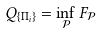Convert formula to latex. <formula><loc_0><loc_0><loc_500><loc_500>Q _ { \{ \Pi _ { i } \} } = \inf _ { \mathcal { P } } F _ { \mathcal { P } }</formula> 